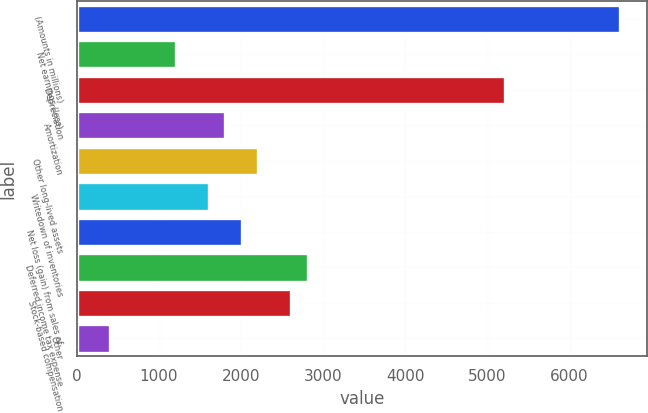Convert chart. <chart><loc_0><loc_0><loc_500><loc_500><bar_chart><fcel>(Amounts in millions)<fcel>Net earnings (loss)<fcel>Depreciation<fcel>Amortization<fcel>Other long-lived assets<fcel>Writedown of inventories<fcel>Net loss (gain) from sales of<fcel>Deferred income tax expense<fcel>Stock-based compensation<fcel>Other<nl><fcel>6615.05<fcel>1205.6<fcel>5212.6<fcel>1806.65<fcel>2207.35<fcel>1606.3<fcel>2007<fcel>2808.4<fcel>2608.05<fcel>404.2<nl></chart> 